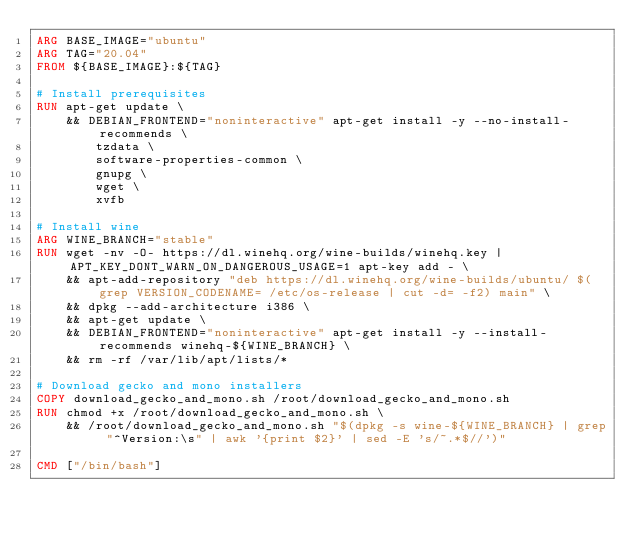<code> <loc_0><loc_0><loc_500><loc_500><_Dockerfile_>ARG BASE_IMAGE="ubuntu"
ARG TAG="20.04"
FROM ${BASE_IMAGE}:${TAG}

# Install prerequisites
RUN apt-get update \
    && DEBIAN_FRONTEND="noninteractive" apt-get install -y --no-install-recommends \
        tzdata \
        software-properties-common \
        gnupg \
        wget \
        xvfb

# Install wine
ARG WINE_BRANCH="stable"
RUN wget -nv -O- https://dl.winehq.org/wine-builds/winehq.key | APT_KEY_DONT_WARN_ON_DANGEROUS_USAGE=1 apt-key add - \
    && apt-add-repository "deb https://dl.winehq.org/wine-builds/ubuntu/ $(grep VERSION_CODENAME= /etc/os-release | cut -d= -f2) main" \
    && dpkg --add-architecture i386 \
    && apt-get update \
    && DEBIAN_FRONTEND="noninteractive" apt-get install -y --install-recommends winehq-${WINE_BRANCH} \
    && rm -rf /var/lib/apt/lists/*

# Download gecko and mono installers
COPY download_gecko_and_mono.sh /root/download_gecko_and_mono.sh
RUN chmod +x /root/download_gecko_and_mono.sh \
    && /root/download_gecko_and_mono.sh "$(dpkg -s wine-${WINE_BRANCH} | grep "^Version:\s" | awk '{print $2}' | sed -E 's/~.*$//')"

CMD ["/bin/bash"]
</code> 